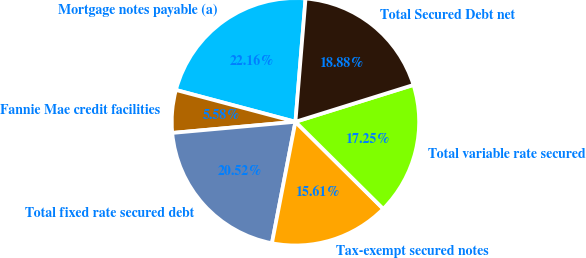Convert chart. <chart><loc_0><loc_0><loc_500><loc_500><pie_chart><fcel>Mortgage notes payable (a)<fcel>Fannie Mae credit facilities<fcel>Total fixed rate secured debt<fcel>Tax-exempt secured notes<fcel>Total variable rate secured<fcel>Total Secured Debt net<nl><fcel>22.16%<fcel>5.58%<fcel>20.52%<fcel>15.61%<fcel>17.25%<fcel>18.88%<nl></chart> 